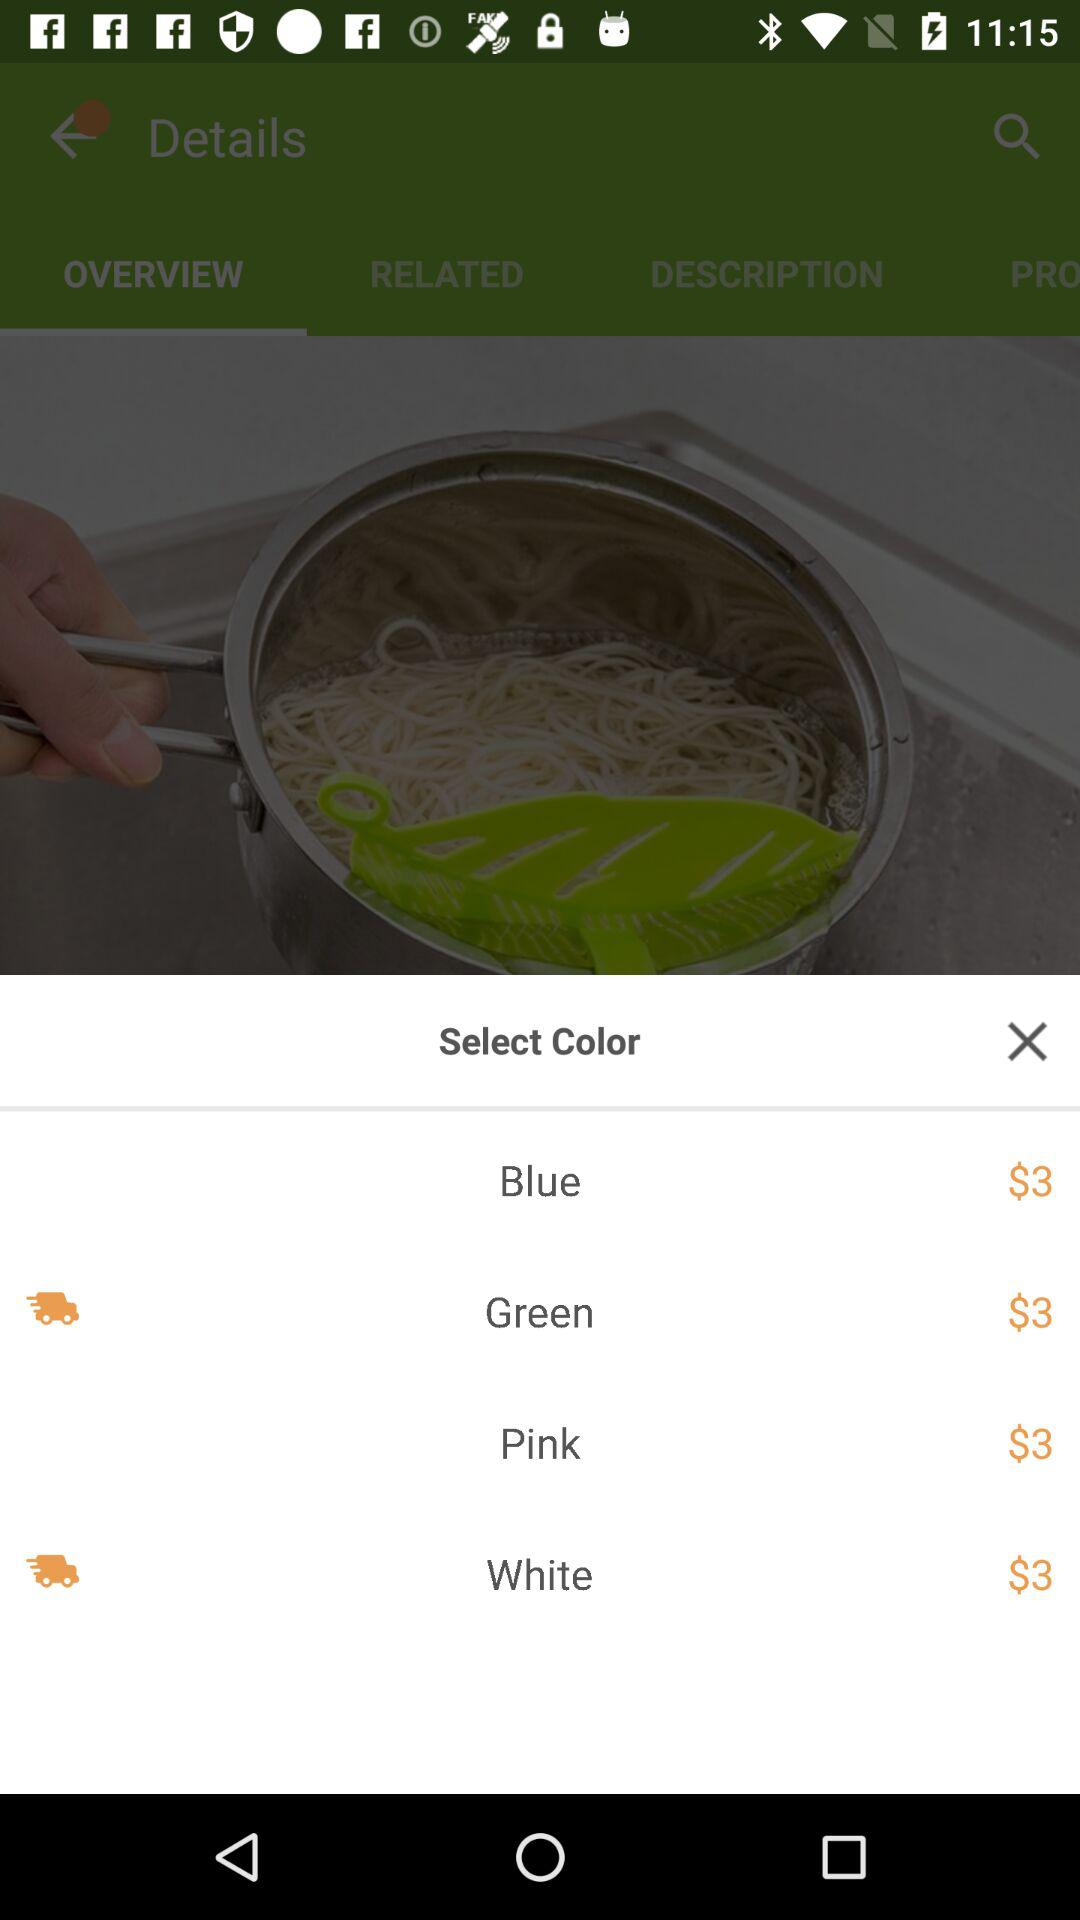How much more does the white color cost than the blue color?
Answer the question using a single word or phrase. 0 